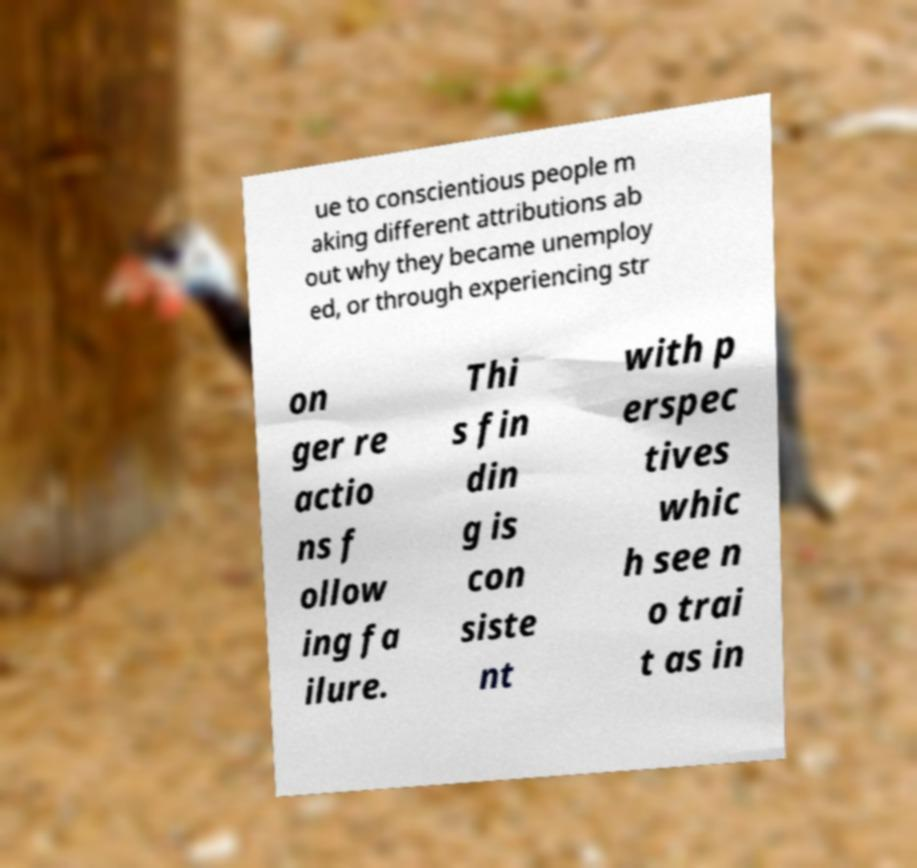For documentation purposes, I need the text within this image transcribed. Could you provide that? ue to conscientious people m aking different attributions ab out why they became unemploy ed, or through experiencing str on ger re actio ns f ollow ing fa ilure. Thi s fin din g is con siste nt with p erspec tives whic h see n o trai t as in 